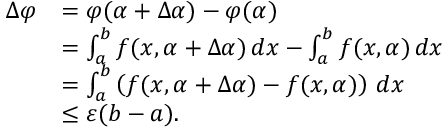<formula> <loc_0><loc_0><loc_500><loc_500>{ \begin{array} { r l } { \Delta \varphi } & { = \varphi ( \alpha + \Delta \alpha ) - \varphi ( \alpha ) } \\ & { = \int _ { a } ^ { b } f ( x , \alpha + \Delta \alpha ) \, d x - \int _ { a } ^ { b } f ( x , \alpha ) \, d x } \\ & { = \int _ { a } ^ { b } \left ( f ( x , \alpha + \Delta \alpha ) - f ( x , \alpha ) \right ) \, d x } \\ & { \leq \varepsilon ( b - a ) . } \end{array} }</formula> 